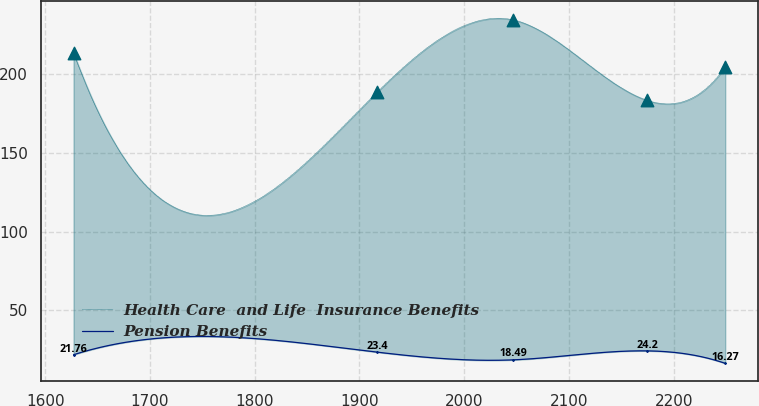Convert chart. <chart><loc_0><loc_0><loc_500><loc_500><line_chart><ecel><fcel>Health Care  and Life  Insurance Benefits<fcel>Pension Benefits<nl><fcel>1627.13<fcel>213.81<fcel>21.76<nl><fcel>1916.78<fcel>188.58<fcel>23.4<nl><fcel>2046.64<fcel>234.64<fcel>18.49<nl><fcel>2174.76<fcel>183.46<fcel>24.2<nl><fcel>2249.2<fcel>204.71<fcel>16.27<nl></chart> 